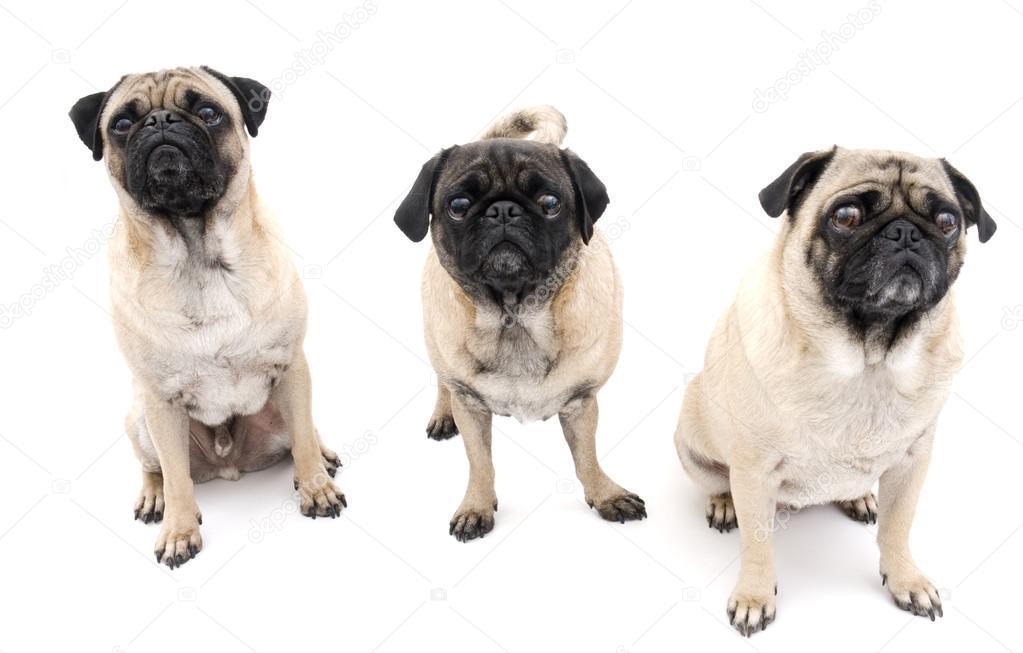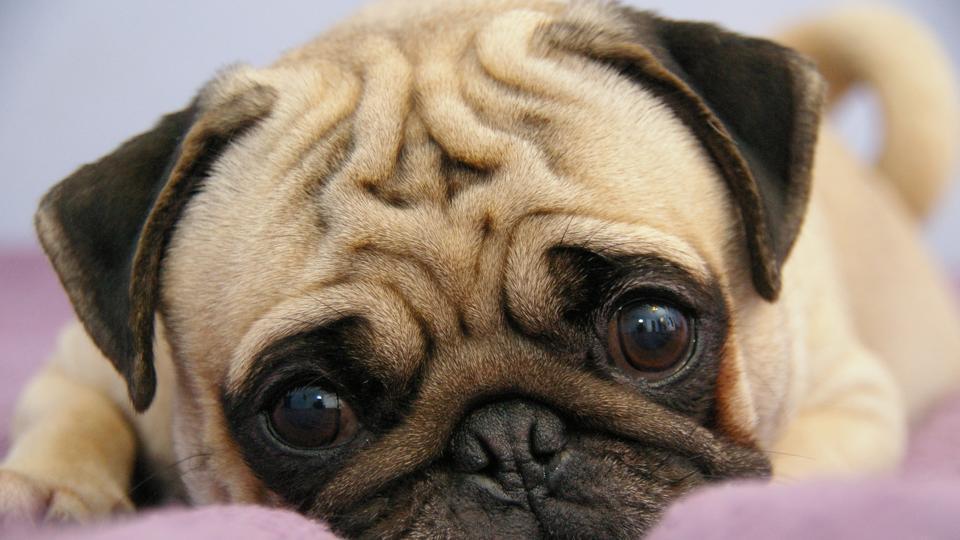The first image is the image on the left, the second image is the image on the right. Assess this claim about the two images: "There are exactly four dogs in total.". Correct or not? Answer yes or no. Yes. The first image is the image on the left, the second image is the image on the right. Given the left and right images, does the statement "The left image contains a row of three pugs, and the right image shows one pug lying flat." hold true? Answer yes or no. Yes. 